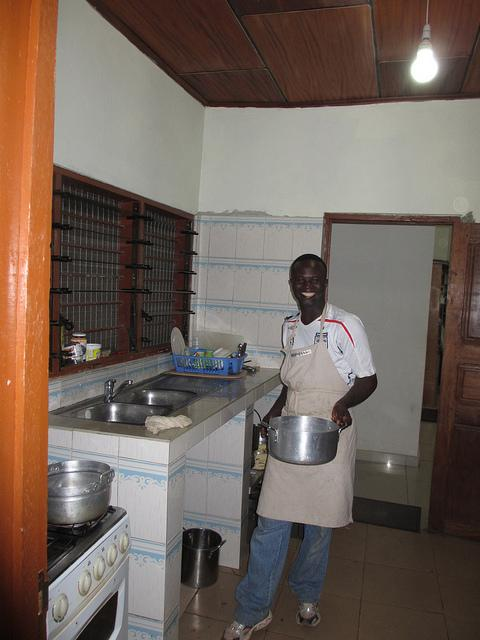This man is in a similar profession to what character? chef 